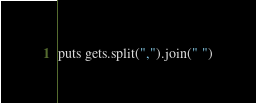Convert code to text. <code><loc_0><loc_0><loc_500><loc_500><_Ruby_>puts gets.split(",").join(" ")</code> 